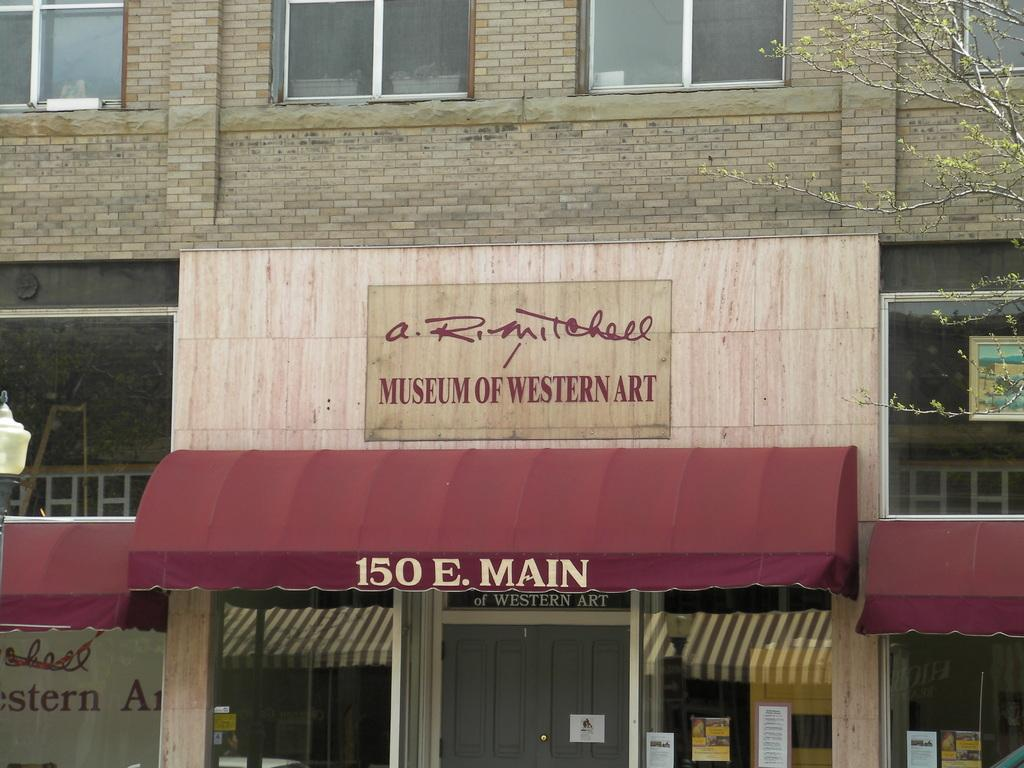What type of structure is present in the image? There is a building in the image. What type of establishment can be found within the building? There is a store in the image. What are the boards used for in the image? The boards are not explicitly described in the facts, so we cannot determine their purpose. What type of vegetation is on the right side of the image? There is a tree on the right side of the image. Can you see any fairies flying around the tree in the image? There is no mention of fairies in the image, so we cannot determine if they are present. What type of tank is visible in the image? There is no tank present in the image. 